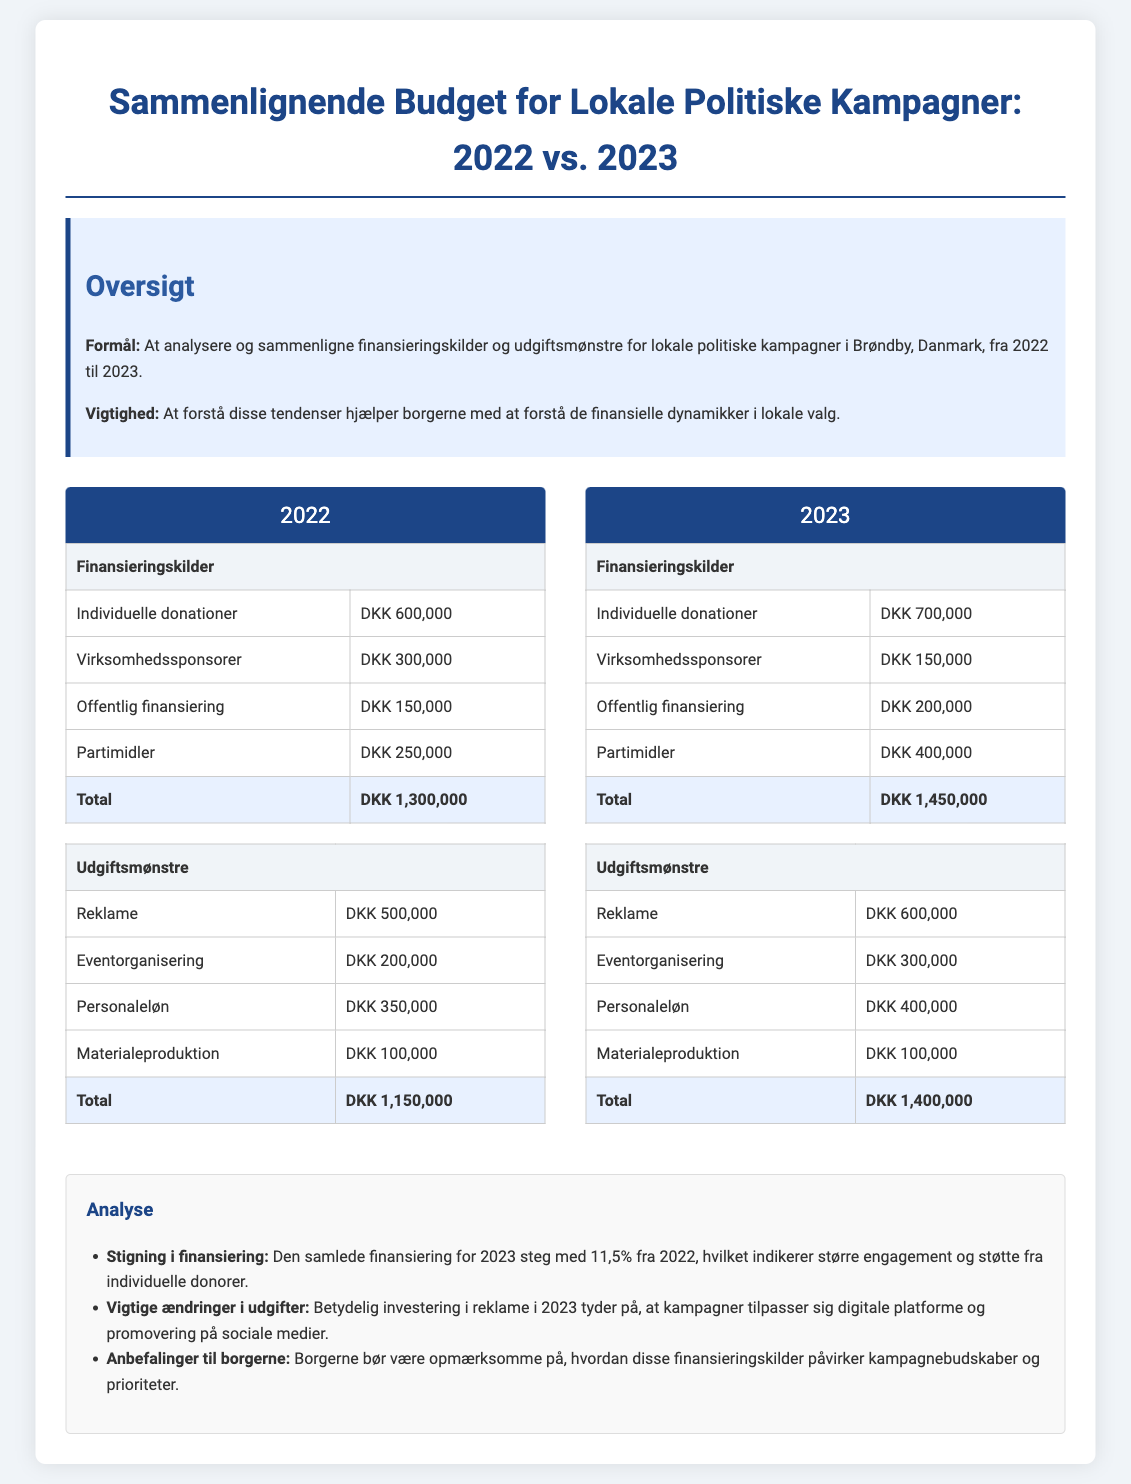What is the total funding for 2022? The total funding for 2022 is listed as DKK 1,300,000 in the document.
Answer: DKK 1,300,000 What is the total expenditure for 2023? The total expenditure for 2023 is summarized as DKK 1,400,000 in the document.
Answer: DKK 1,400,000 How much did individual donations increase from 2022 to 2023? The increase in individual donations from 2022 to 2023 is calculated by subtracting DKK 600,000 from DKK 700,000, which is DKK 100,000.
Answer: DKK 100,000 What is the largest source of funding in 2022? The largest source of funding in 2022 is individual donations at DKK 600,000.
Answer: Individual donations What category had the highest expenditure in 2023? The highest expenditure category in 2023 is advertising at DKK 600,000.
Answer: Advertising What was the total amount of public funding for 2023? The document states that public funding for 2023 amounts to DKK 200,000.
Answer: DKK 200,000 How much did corporate sponsorships decline from 2022 to 2023? Corporate sponsorships decreased from DKK 300,000 in 2022 to DKK 150,000 in 2023, amounting to a decline of DKK 150,000.
Answer: DKK 150,000 What percentage increase is observed in total funding from 2022 to 2023? The percentage increase is calculated as (DKK 1,450,000 - DKK 1,300,000) / DKK 1,300,000 * 100, resulting in an increase of 11.5%.
Answer: 11.5% What is a recommendation for citizens provided in the analysis? The document advises that citizens should be aware of how funding sources influence campaign messages and priorities.
Answer: Funding sources influence campaign messages 